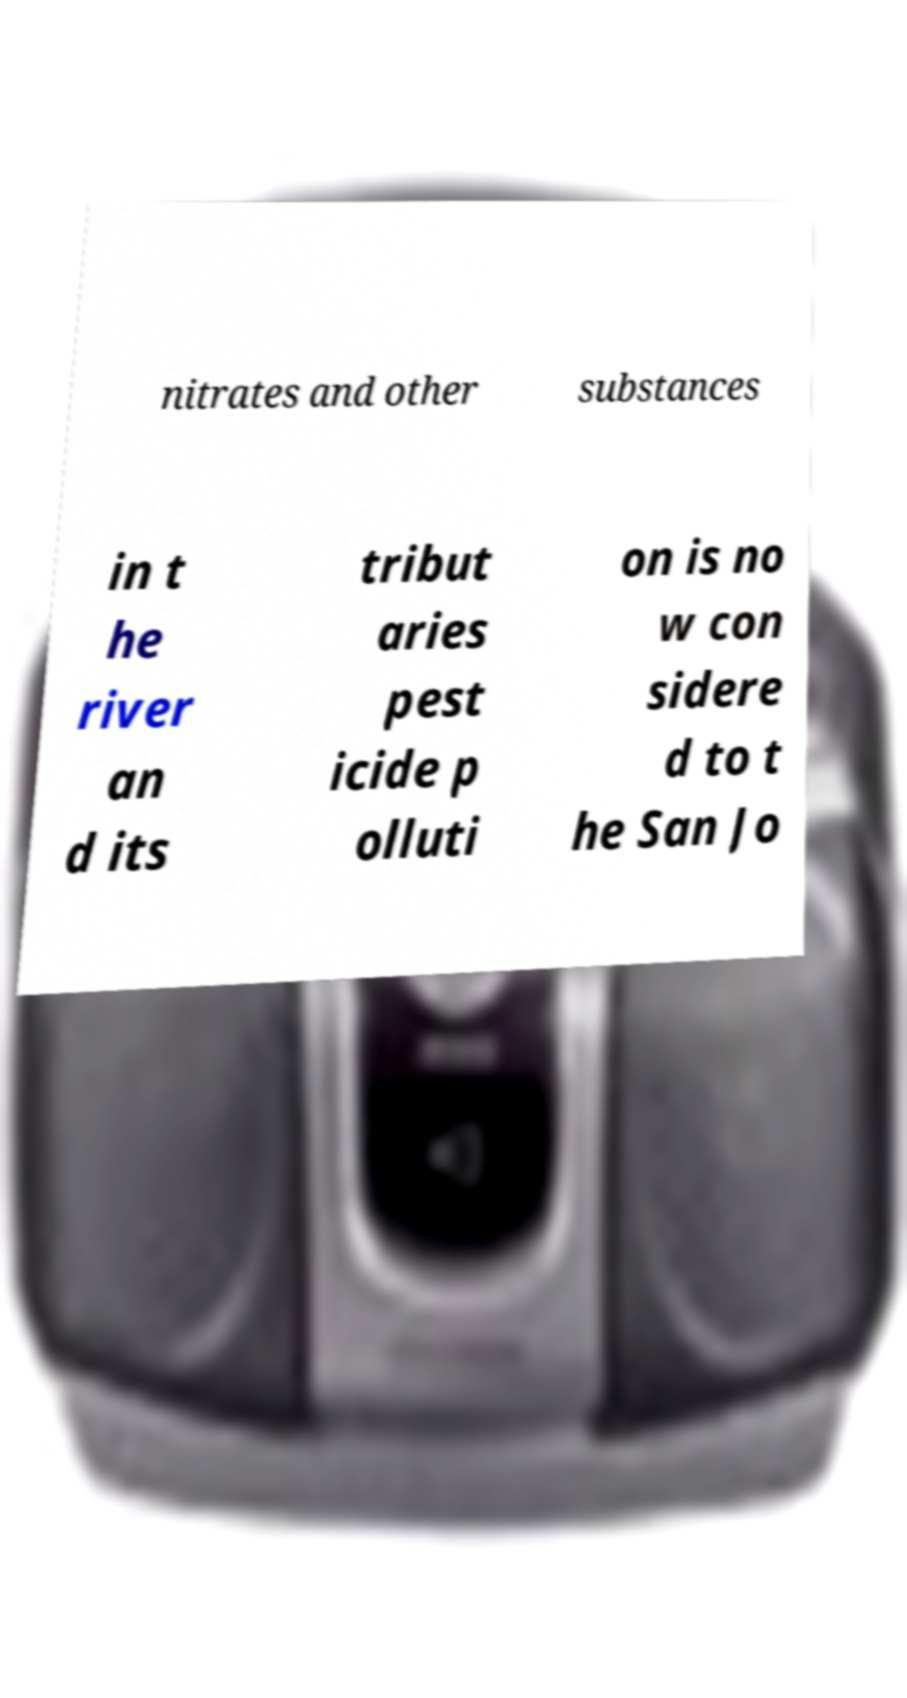Could you assist in decoding the text presented in this image and type it out clearly? nitrates and other substances in t he river an d its tribut aries pest icide p olluti on is no w con sidere d to t he San Jo 